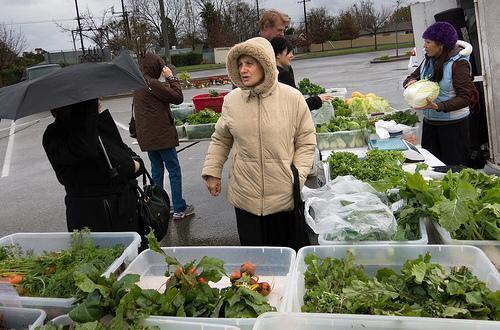How many people have umbrellas?
Give a very brief answer. 1. 